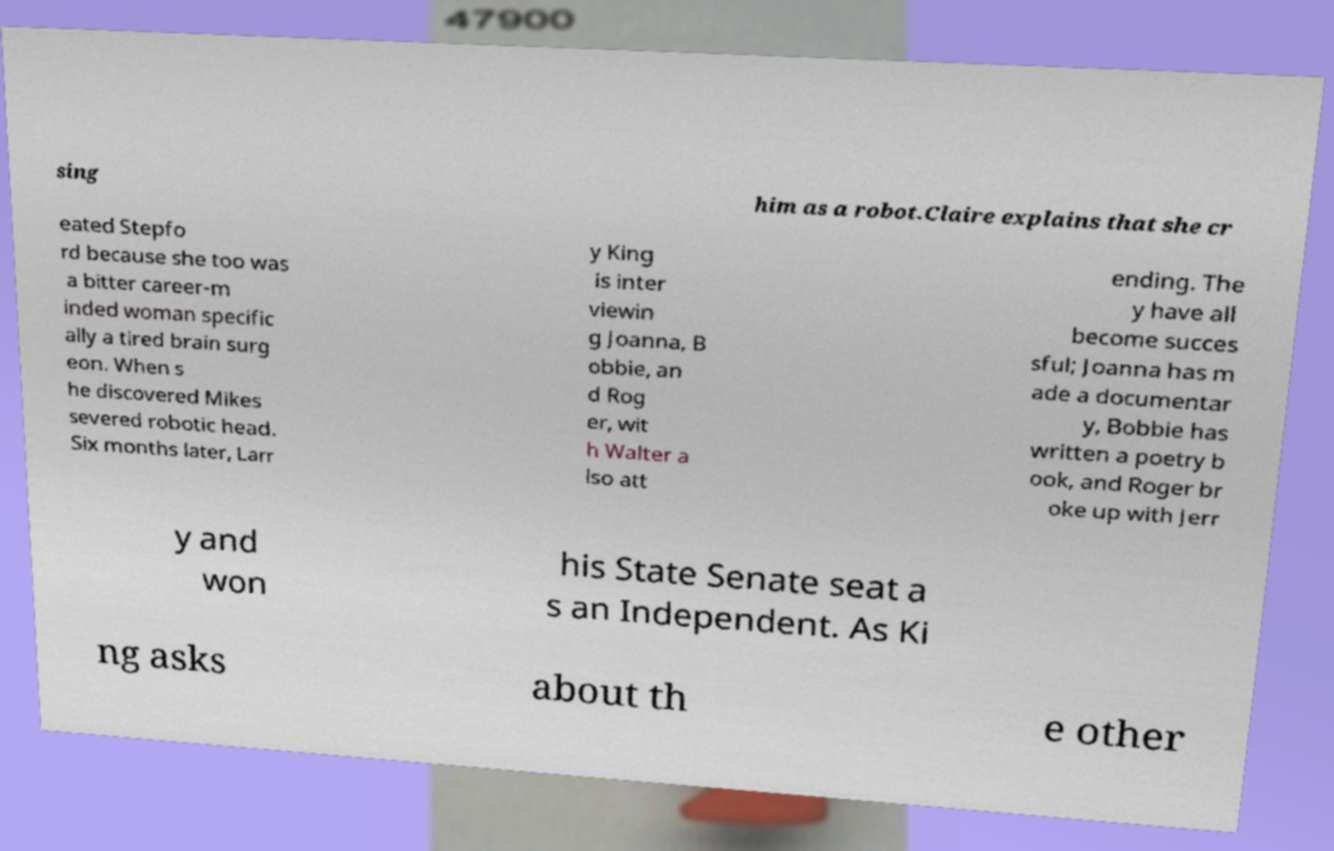Can you accurately transcribe the text from the provided image for me? sing him as a robot.Claire explains that she cr eated Stepfo rd because she too was a bitter career-m inded woman specific ally a tired brain surg eon. When s he discovered Mikes severed robotic head. Six months later, Larr y King is inter viewin g Joanna, B obbie, an d Rog er, wit h Walter a lso att ending. The y have all become succes sful; Joanna has m ade a documentar y, Bobbie has written a poetry b ook, and Roger br oke up with Jerr y and won his State Senate seat a s an Independent. As Ki ng asks about th e other 